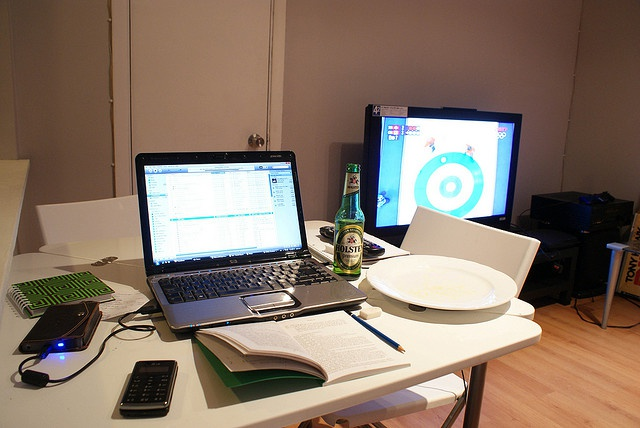Describe the objects in this image and their specific colors. I can see dining table in black, ivory, and tan tones, laptop in black, white, gray, and lightblue tones, tv in black, white, and lightblue tones, tv in black, white, and lightblue tones, and book in black, ivory, tan, and gray tones in this image. 